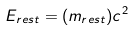Convert formula to latex. <formula><loc_0><loc_0><loc_500><loc_500>E _ { r e s t } = ( m _ { r e s t } ) c ^ { 2 }</formula> 